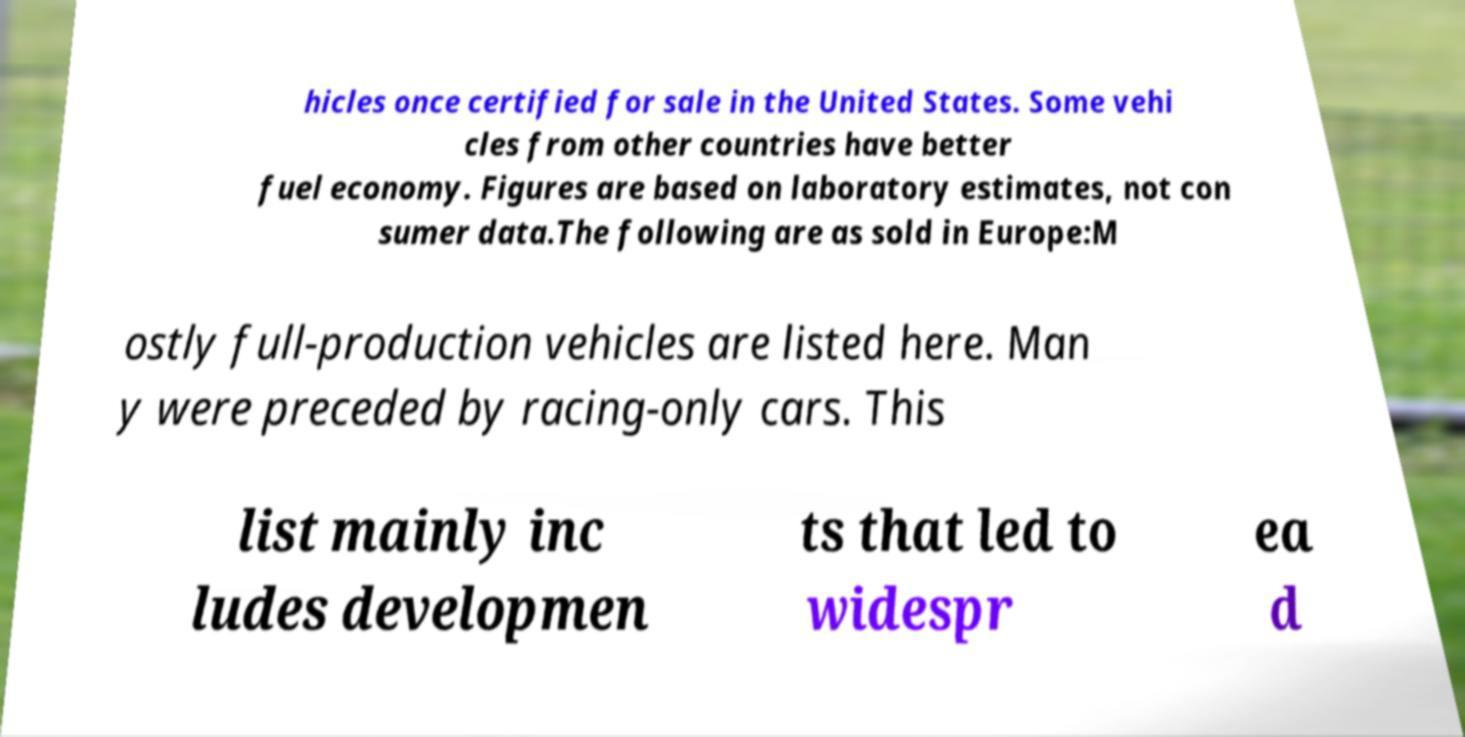Please read and relay the text visible in this image. What does it say? hicles once certified for sale in the United States. Some vehi cles from other countries have better fuel economy. Figures are based on laboratory estimates, not con sumer data.The following are as sold in Europe:M ostly full-production vehicles are listed here. Man y were preceded by racing-only cars. This list mainly inc ludes developmen ts that led to widespr ea d 